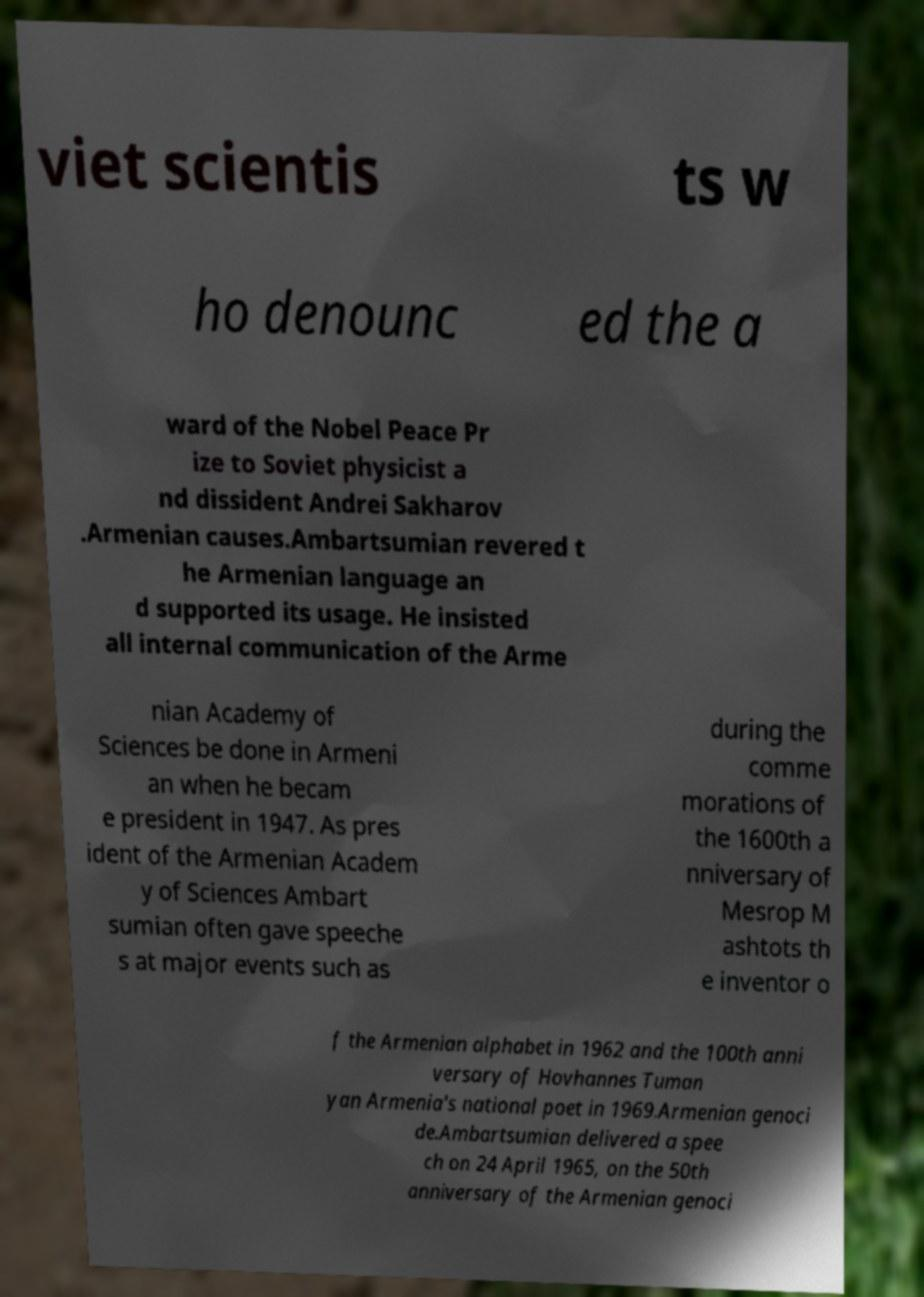Please read and relay the text visible in this image. What does it say? viet scientis ts w ho denounc ed the a ward of the Nobel Peace Pr ize to Soviet physicist a nd dissident Andrei Sakharov .Armenian causes.Ambartsumian revered t he Armenian language an d supported its usage. He insisted all internal communication of the Arme nian Academy of Sciences be done in Armeni an when he becam e president in 1947. As pres ident of the Armenian Academ y of Sciences Ambart sumian often gave speeche s at major events such as during the comme morations of the 1600th a nniversary of Mesrop M ashtots th e inventor o f the Armenian alphabet in 1962 and the 100th anni versary of Hovhannes Tuman yan Armenia's national poet in 1969.Armenian genoci de.Ambartsumian delivered a spee ch on 24 April 1965, on the 50th anniversary of the Armenian genoci 